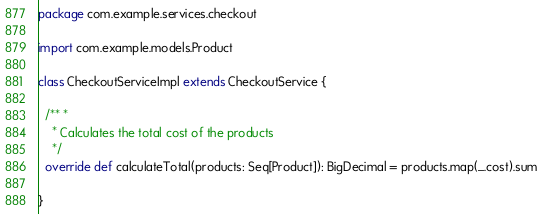<code> <loc_0><loc_0><loc_500><loc_500><_Scala_>package com.example.services.checkout

import com.example.models.Product

class CheckoutServiceImpl extends CheckoutService {

  /** *
    * Calculates the total cost of the products
    */
  override def calculateTotal(products: Seq[Product]): BigDecimal = products.map(_.cost).sum

}
</code> 